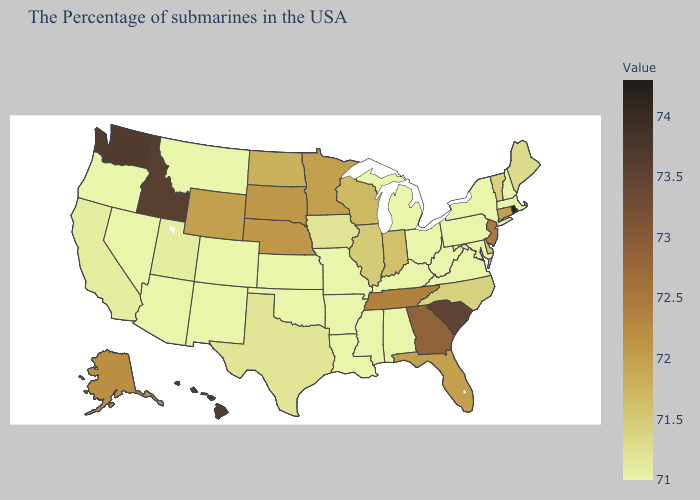Does New York have the highest value in the Northeast?
Write a very short answer. No. Among the states that border Vermont , which have the highest value?
Keep it brief. Massachusetts, New Hampshire, New York. Which states have the lowest value in the USA?
Write a very short answer. Massachusetts, New Hampshire, New York, Maryland, Pennsylvania, Virginia, West Virginia, Ohio, Michigan, Kentucky, Alabama, Mississippi, Louisiana, Missouri, Arkansas, Kansas, Oklahoma, Colorado, New Mexico, Montana, Arizona, Nevada, Oregon. Which states have the lowest value in the South?
Be succinct. Maryland, Virginia, West Virginia, Kentucky, Alabama, Mississippi, Louisiana, Arkansas, Oklahoma. Which states have the lowest value in the USA?
Answer briefly. Massachusetts, New Hampshire, New York, Maryland, Pennsylvania, Virginia, West Virginia, Ohio, Michigan, Kentucky, Alabama, Mississippi, Louisiana, Missouri, Arkansas, Kansas, Oklahoma, Colorado, New Mexico, Montana, Arizona, Nevada, Oregon. Among the states that border Wisconsin , which have the lowest value?
Give a very brief answer. Michigan. 